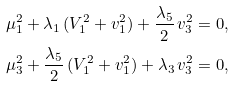<formula> <loc_0><loc_0><loc_500><loc_500>\mu _ { 1 } ^ { 2 } & + \lambda _ { 1 } \, ( V _ { 1 } ^ { 2 } + v _ { 1 } ^ { 2 } ) + \frac { \lambda _ { 5 } } { 2 } \, v _ { 3 } ^ { 2 } = 0 , \\ \mu _ { 3 } ^ { 2 } & + \frac { \lambda _ { 5 } } { 2 } \, ( V _ { 1 } ^ { 2 } + v _ { 1 } ^ { 2 } ) + \lambda _ { 3 } \, v _ { 3 } ^ { 2 } = 0 ,</formula> 